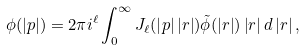<formula> <loc_0><loc_0><loc_500><loc_500>\phi ( \left | { p } \right | ) = 2 \pi i ^ { \ell } \int _ { 0 } ^ { \infty } J _ { \ell } ( \left | { p } \right | \left | { r } \right | ) \tilde { \phi } ( \left | { r } \right | ) \left | { r } \right | d \left | { r } \right | ,</formula> 